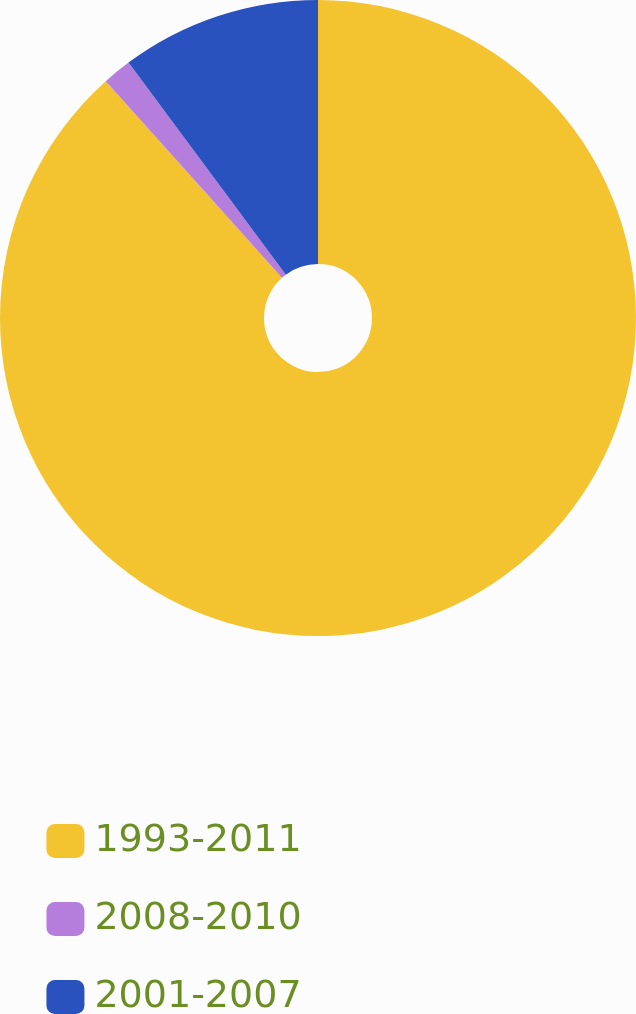Convert chart. <chart><loc_0><loc_0><loc_500><loc_500><pie_chart><fcel>1993-2011<fcel>2008-2010<fcel>2001-2007<nl><fcel>88.37%<fcel>1.47%<fcel>10.16%<nl></chart> 